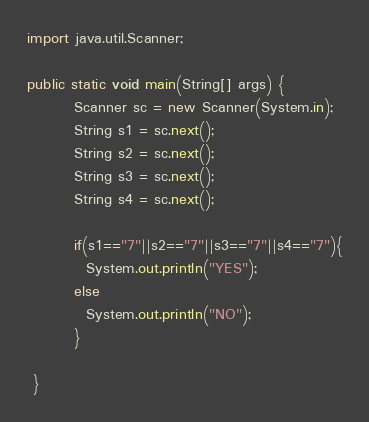Convert code to text. <code><loc_0><loc_0><loc_500><loc_500><_Java_>import java.util.Scanner;

public static void main(String[] args) {
        Scanner sc = new Scanner(System.in);
        String s1 = sc.next();
		String s2 = sc.next();
  		String s3 = sc.next();
  		String s4 = sc.next();

        if(s1=="7"||s2=="7"||s3=="7"||s4=="7"){
          System.out.println("YES");
        else
          System.out.println("NO");
        } 
            
 }
</code> 